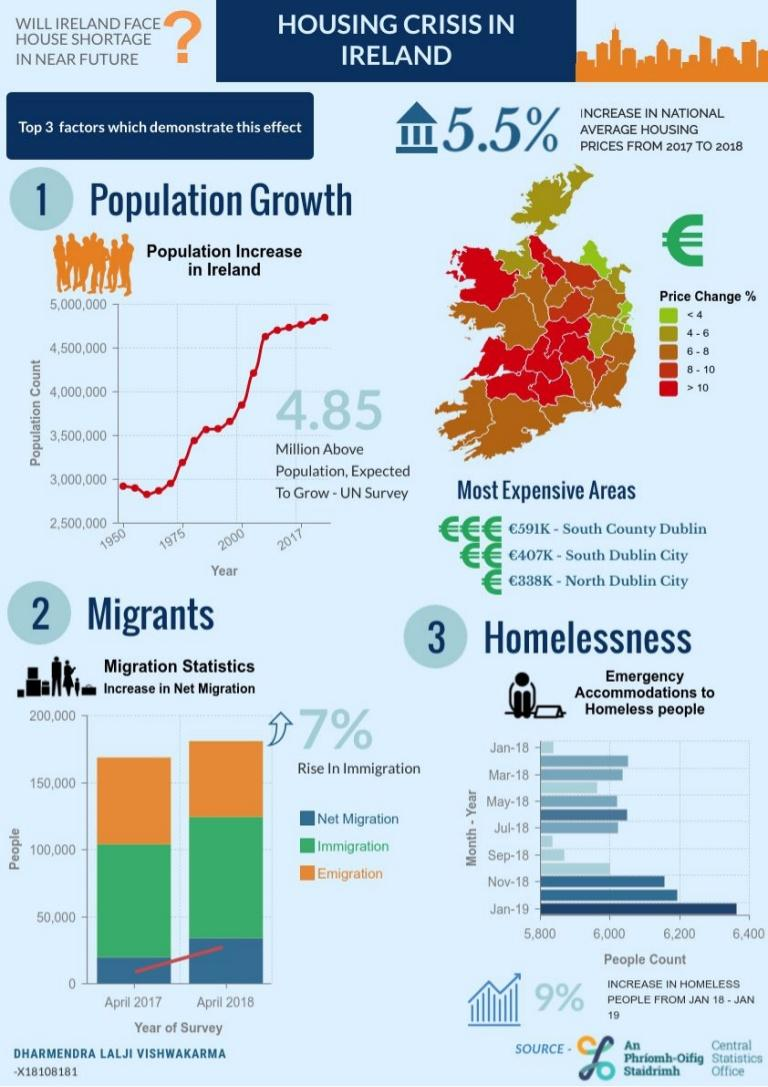Identify some key points in this picture. The housing shortage problem in Ireland is affected by several factors, including population growth, migrants, and homelessness. 